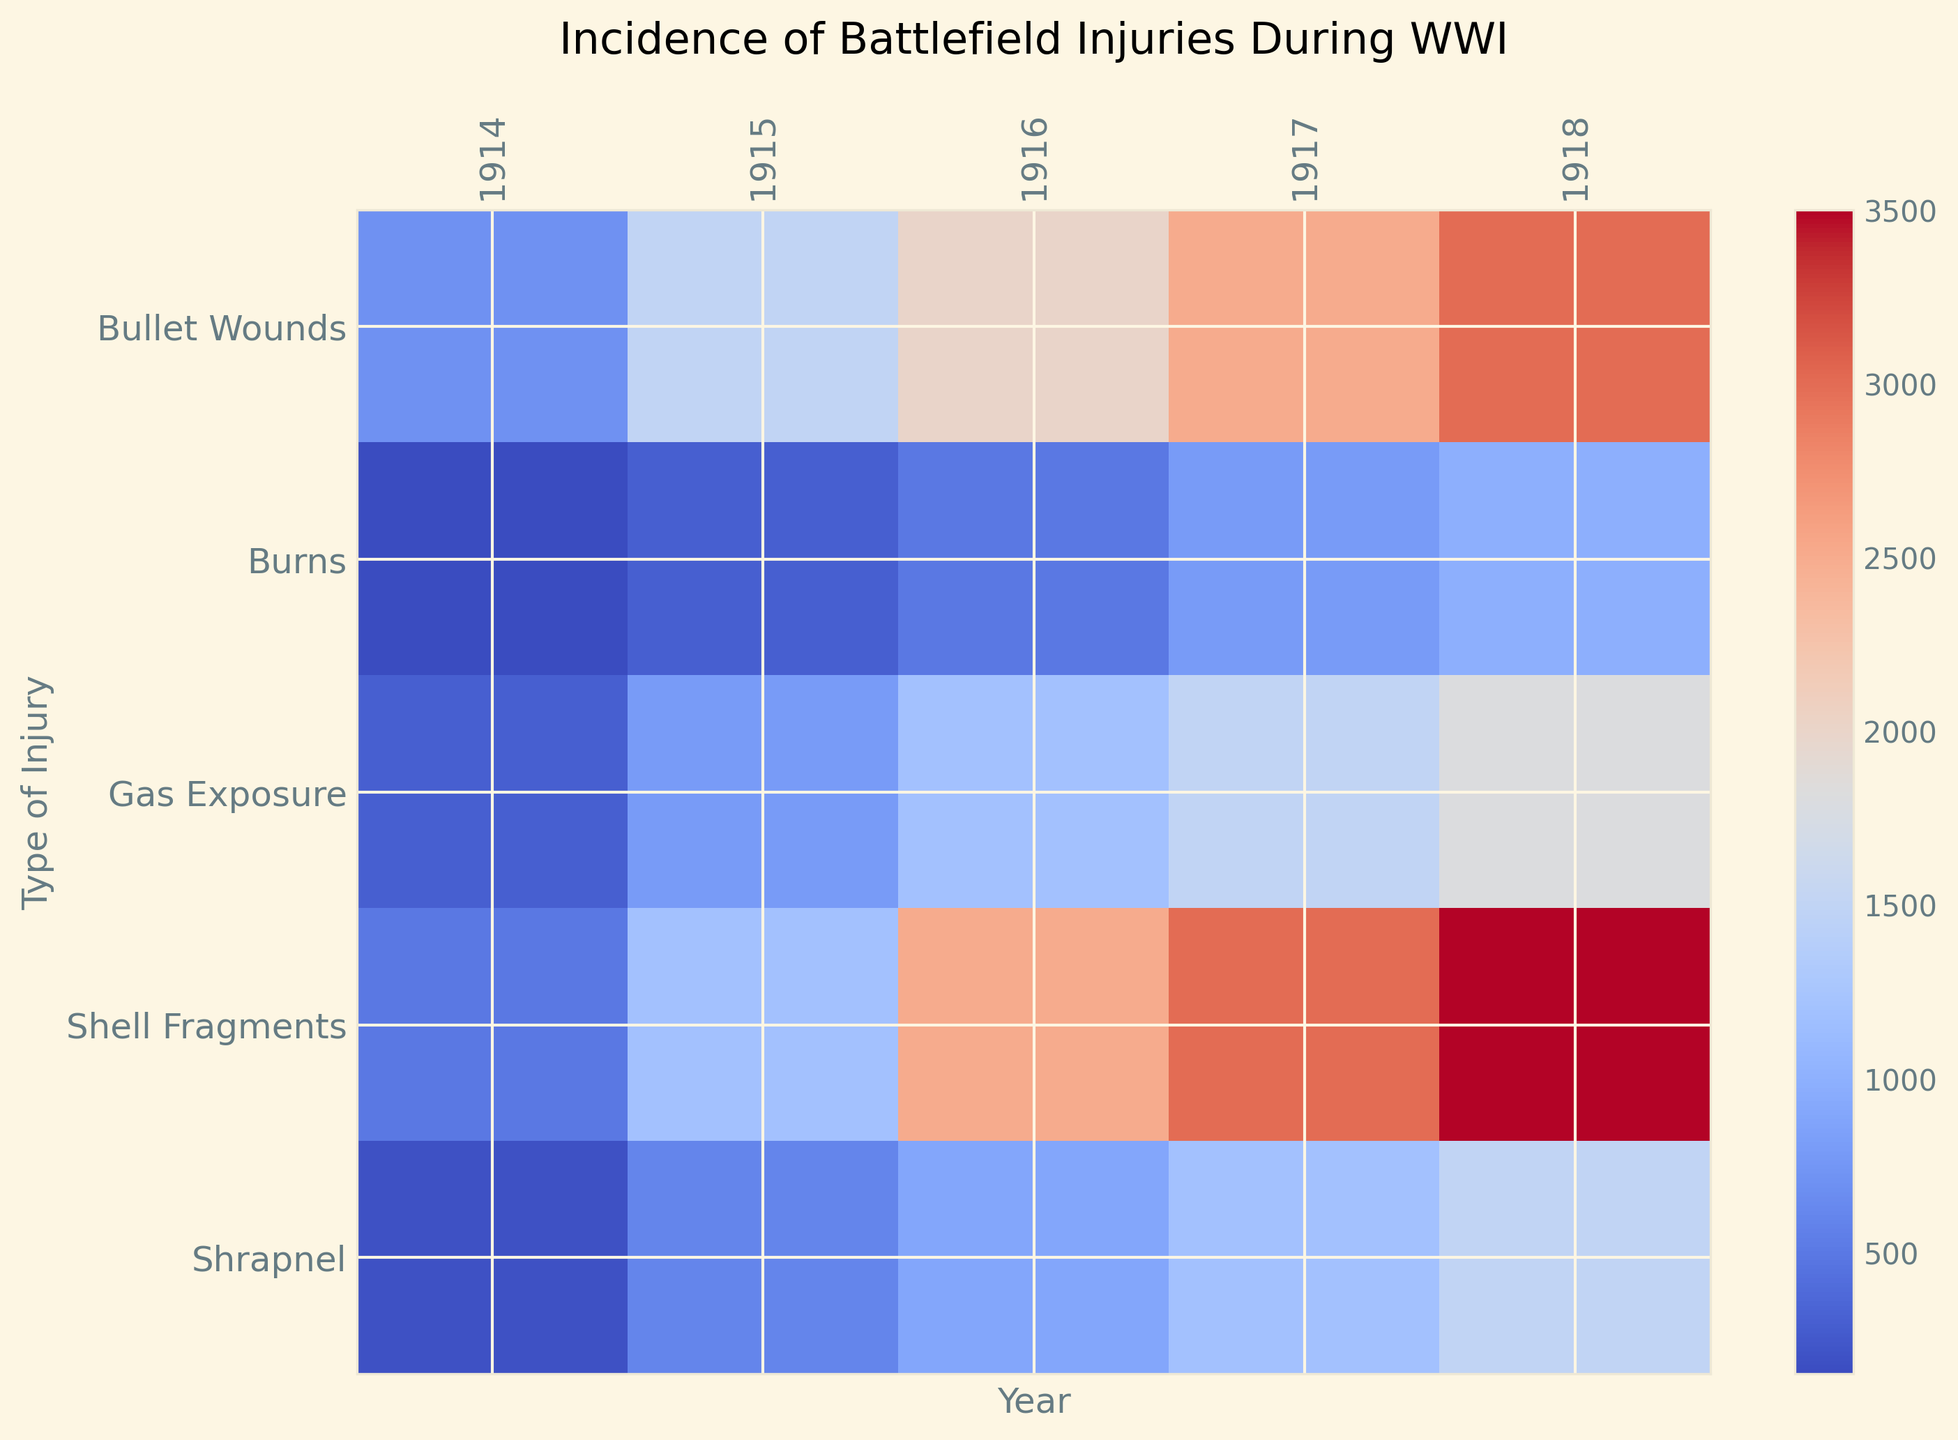Which year had the highest incidence of battlefield injuries for Shell Fragments? By observing the row corresponding to 'Shell Fragments' and comparing the values across different years, we can see that 1918 has the highest incidence value of 3500.
Answer: 1918 What type of injury had the highest incidence in 1916? By looking at the column corresponding to 1916 and comparing the values for each injury type, 'Shell Fragments' had the highest incidence with a value of 2500.
Answer: Shell Fragments Between 1914 and 1918, which injury type showed the greatest increase in incidence? We calculate the difference in incidence from 1914 to 1918 for each injury type. The differences are: Shell Fragments: 3500-500=3000, Bullet Wounds: 3000-700=2300, Gas Exposure: 1800-300=1500, Shrapnel: 1500-200=1300, Burns: 1000-150=850. 'Shell Fragments' showed the greatest increase.
Answer: Shell Fragments How did the incidence of Gas Exposure change from 1915 to 1917? Look at the values for Gas Exposure in 1915 and 1917 and calculate the difference: 1500 (1917) - 800 (1915) = 700. The incidence increased by 700.
Answer: Increased by 700 Which year had the lowest total incidence of battlefield injuries? Sum all injury types for each year and compare: 1914: 1850, 1915: 4400, 1916: 7100, 1917: 9000, 1918: 10800. The lowest total incidence is in 1914 with 1850.
Answer: 1914 Is the incidence of Bullet Wounds in 1918 higher than the incidence of Gas Exposure in 1916? Compare the values for Bullet Wounds in 1918 (3000) and Gas Exposure in 1916 (1200). Since 3000 > 1200, the incidence of Bullet Wounds in 1918 is higher.
Answer: Yes Which type of injury shows the most consistent increase across all years? By examining each type of injury year by year: Shell Fragments increases steadily from 500 to 3500, Bullet Wounds from 700 to 3000, Gas Exposure from 300 to 1800, Shrapnel from 200 to 1500, Burns from 150 to 1000. 'Shell Fragments' has the most consistent increase.
Answer: Shell Fragments 